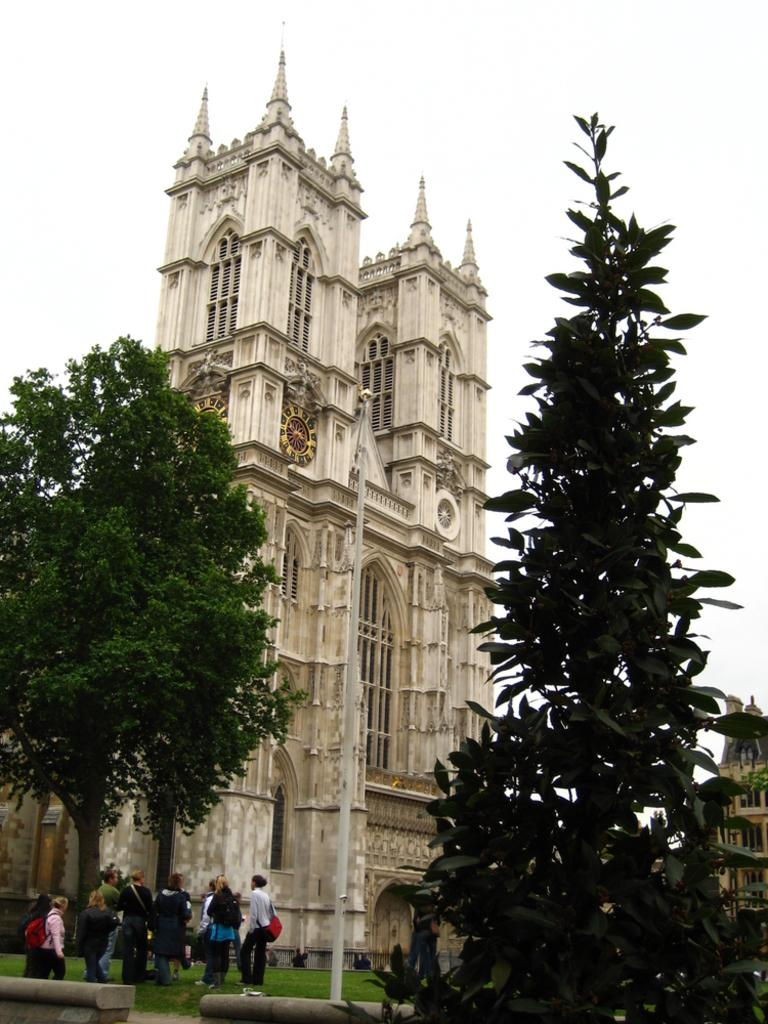What can be seen on the ground in the image? There are people on the ground in the image. What object is present in the image that is typically used for support or signage? There is a pole in the image. What type of natural vegetation is visible in the image? There are trees in the image. What type of man-made structures can be seen in the image? There are buildings in the image. What is visible in the background of the image? The sky is visible in the background of the image. What type of crack is visible on the stove in the image? There is no stove or crack present in the image. What is the governor doing in the image? There is no governor present in the image. 